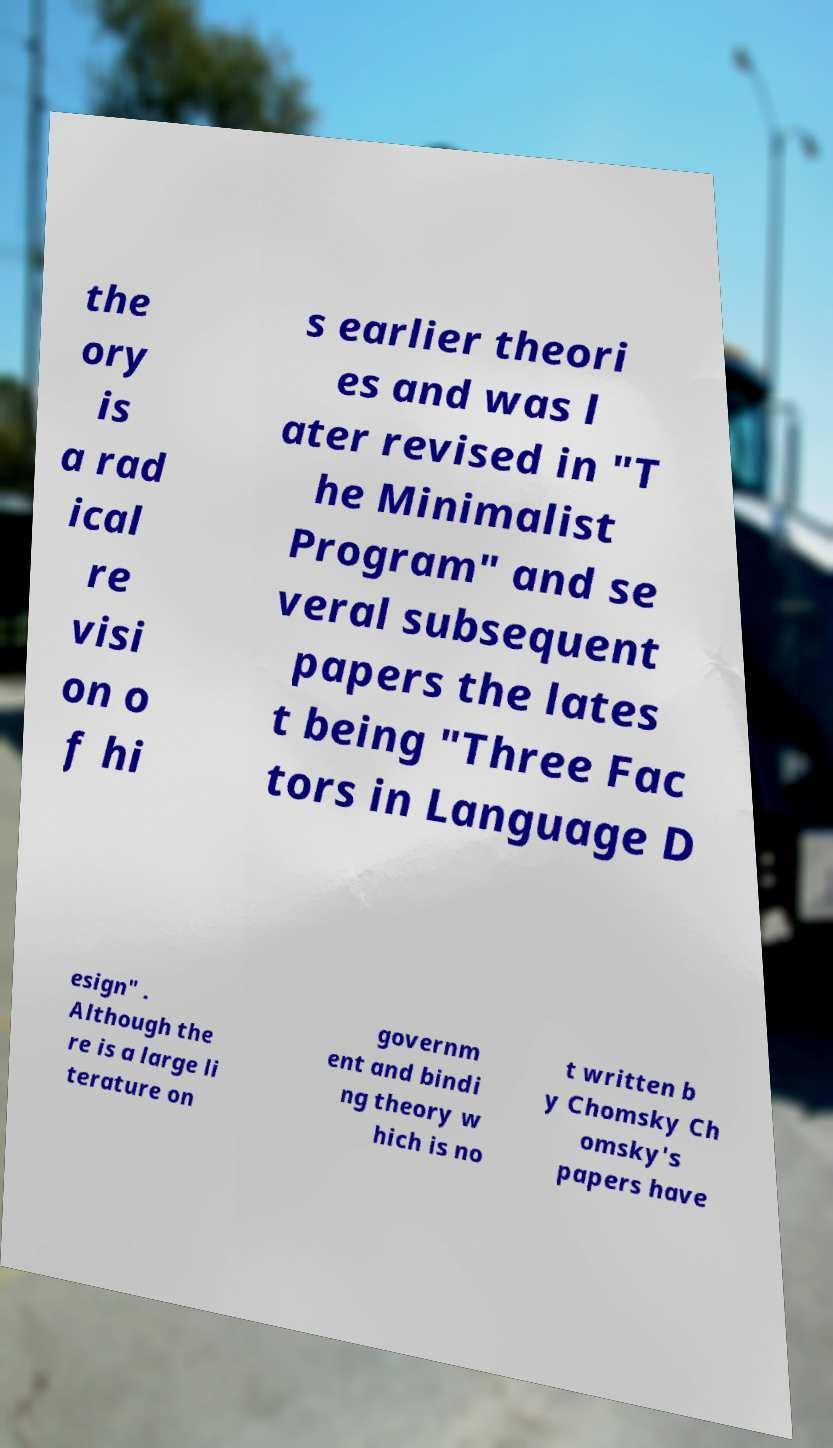What messages or text are displayed in this image? I need them in a readable, typed format. the ory is a rad ical re visi on o f hi s earlier theori es and was l ater revised in "T he Minimalist Program" and se veral subsequent papers the lates t being "Three Fac tors in Language D esign" . Although the re is a large li terature on governm ent and bindi ng theory w hich is no t written b y Chomsky Ch omsky's papers have 